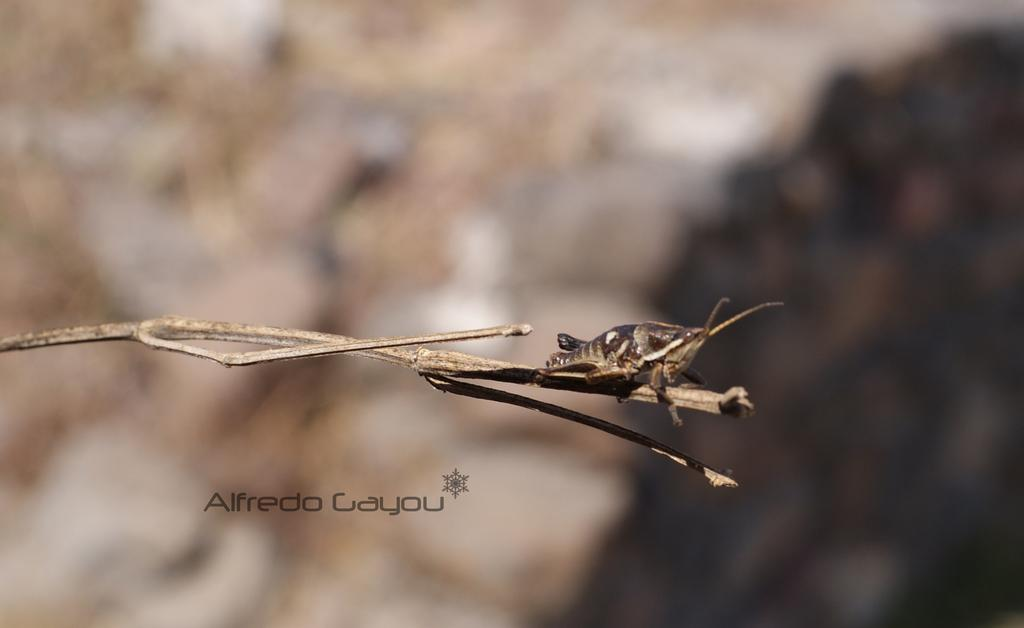What is present on the branch in the foreground of the image? There is an insect on the branch of a tree in the foreground. What can be seen in the foreground besides the insect? There is a text in the foreground. What colors are predominant in the background of the image? The background color is white and brown. Can you determine the time of day the image was taken? The image was likely taken during the day, as there is no indication of darkness or artificial lighting. What type of dress is the insect wearing in the image? Insects do not wear dresses, as they are not human and do not have the ability to wear clothing. 